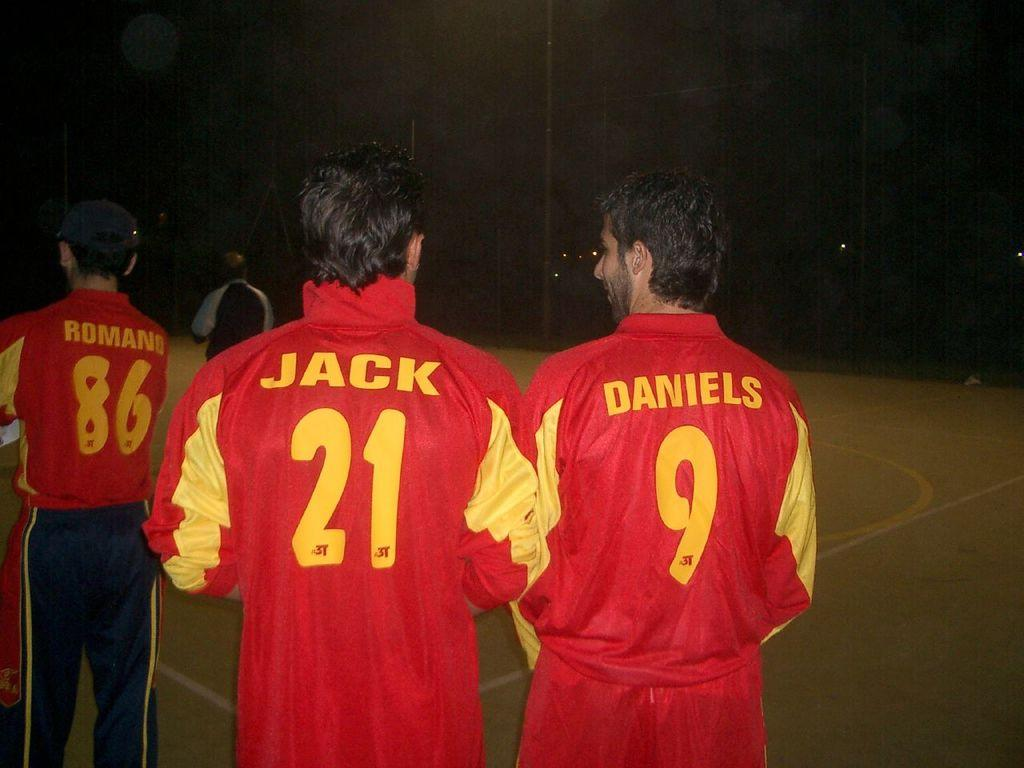<image>
Provide a brief description of the given image. A guy in a jacket with the name Jack on it walks with someone else. 